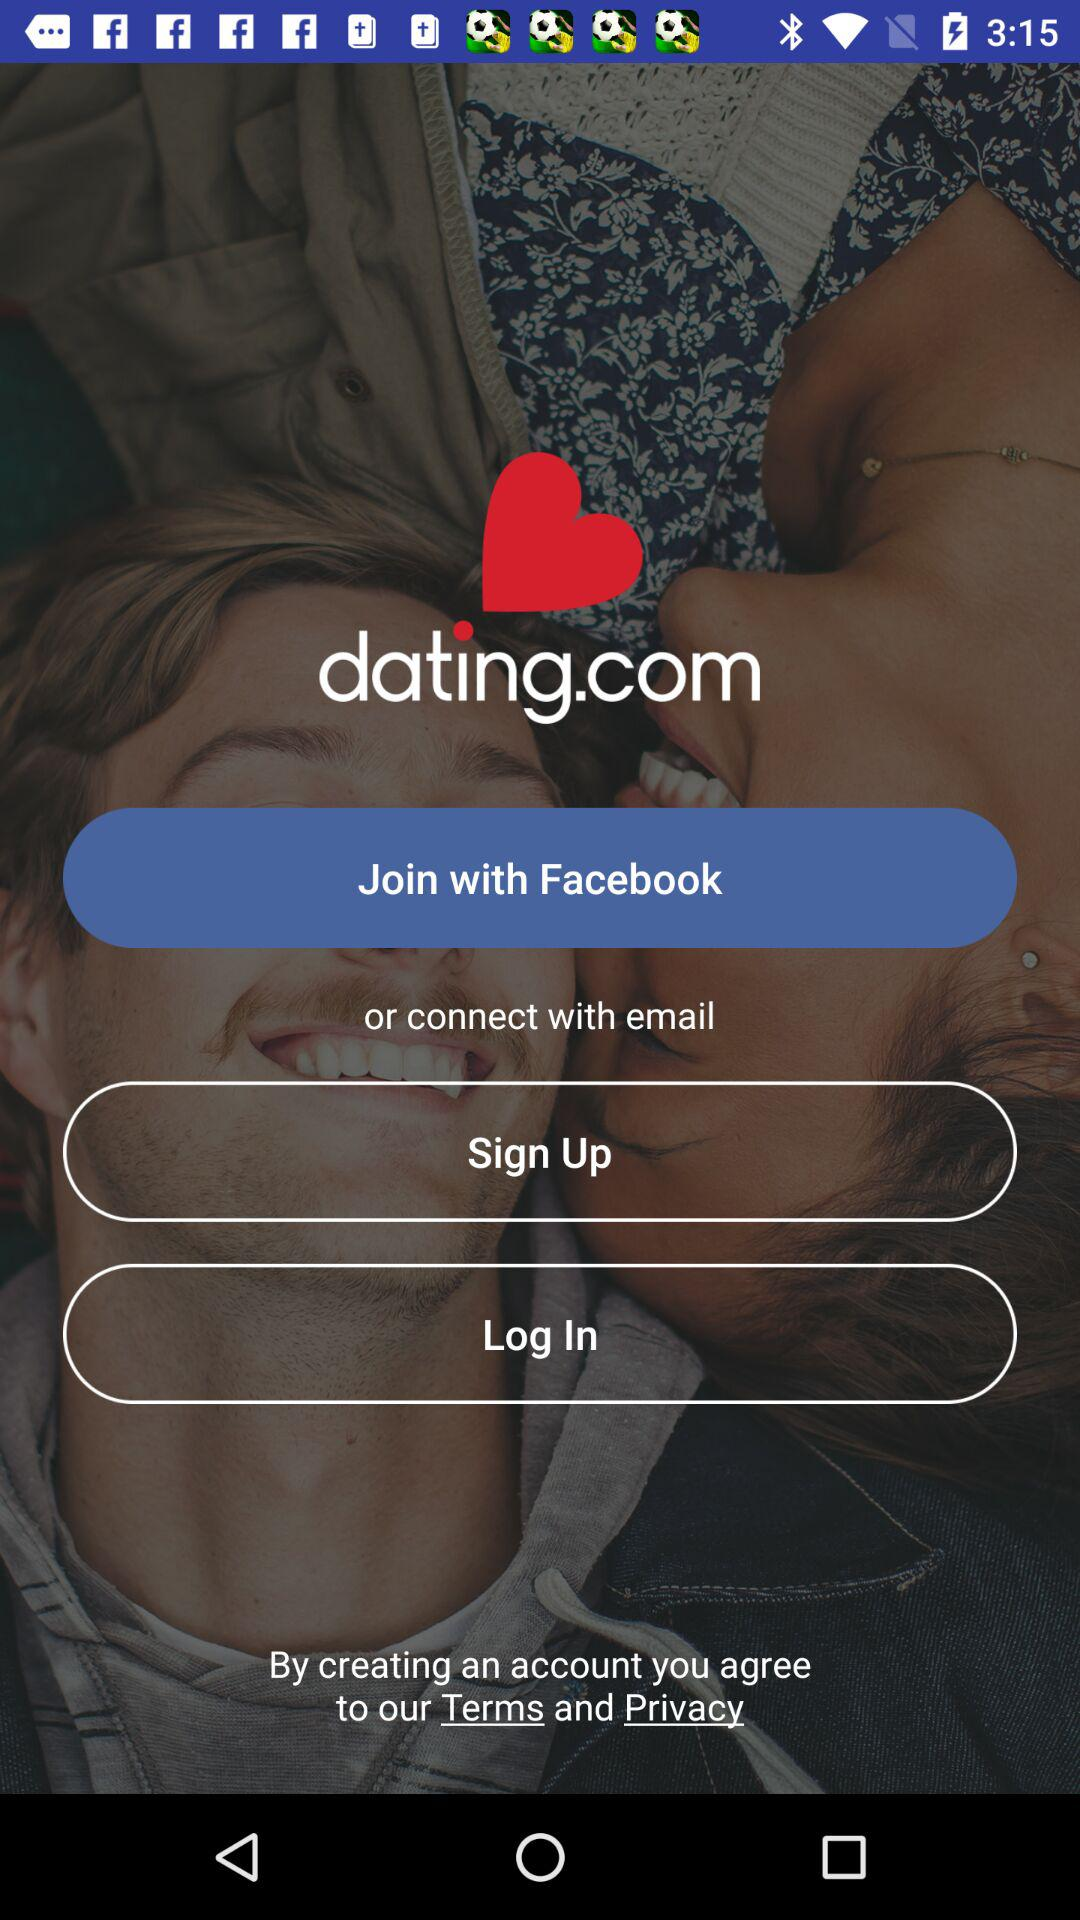What is the name of the application? The name of the application is "dating.com". 